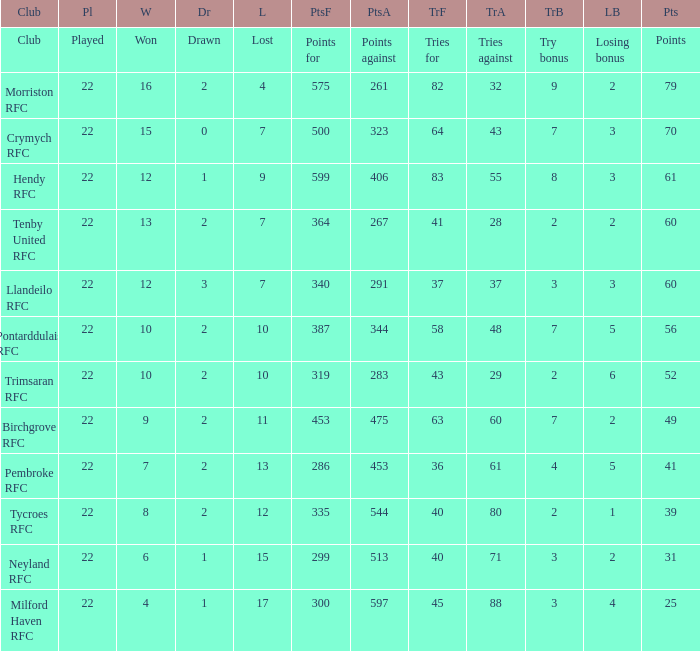What's the points with tries for being 64 70.0. 